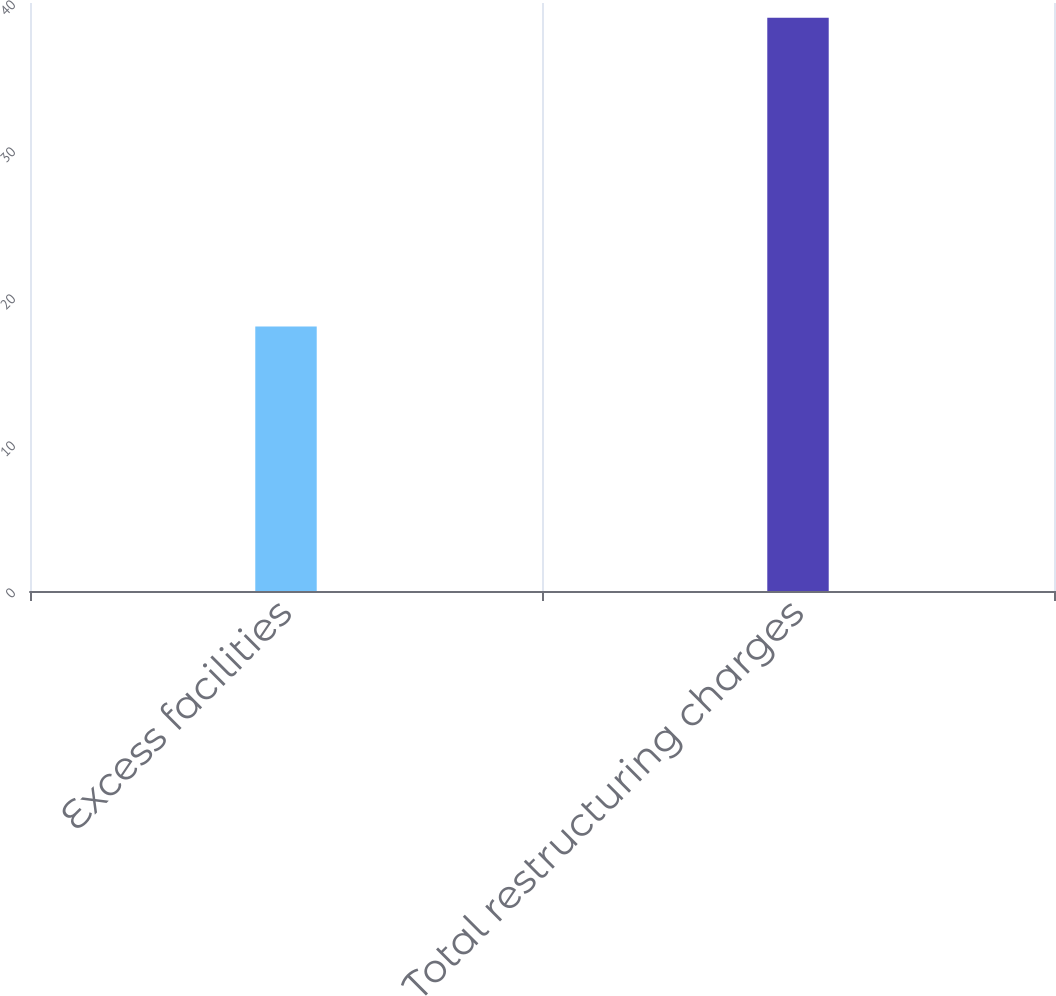<chart> <loc_0><loc_0><loc_500><loc_500><bar_chart><fcel>Excess facilities<fcel>Total restructuring charges<nl><fcel>18<fcel>39<nl></chart> 